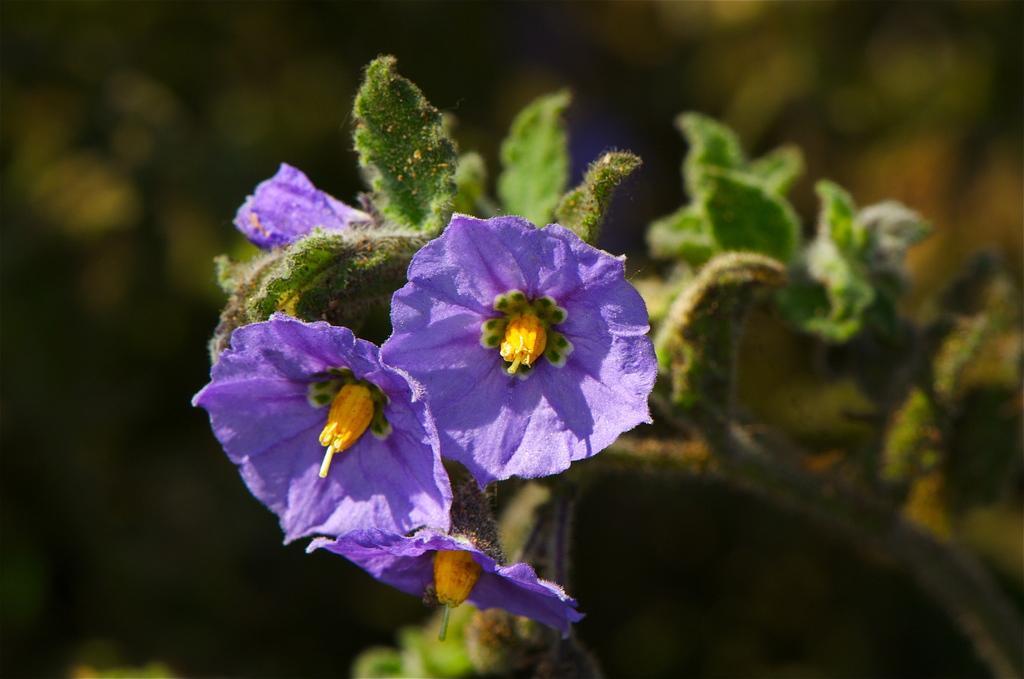Could you give a brief overview of what you see in this image? In this image in the foreground there are some flowers and plants, in the background there are plants. 